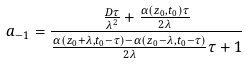<formula> <loc_0><loc_0><loc_500><loc_500>a _ { - 1 } = \frac { \frac { D \tau } { \lambda ^ { 2 } } + \frac { \alpha \left ( z _ { 0 } , t _ { 0 } \right ) \tau } { 2 \lambda } } { \frac { \alpha \left ( z _ { 0 } + \lambda , t _ { 0 } - \tau \right ) - \alpha \left ( z _ { 0 } - \lambda , t _ { 0 } - \tau \right ) } { 2 \lambda } \tau + 1 }</formula> 